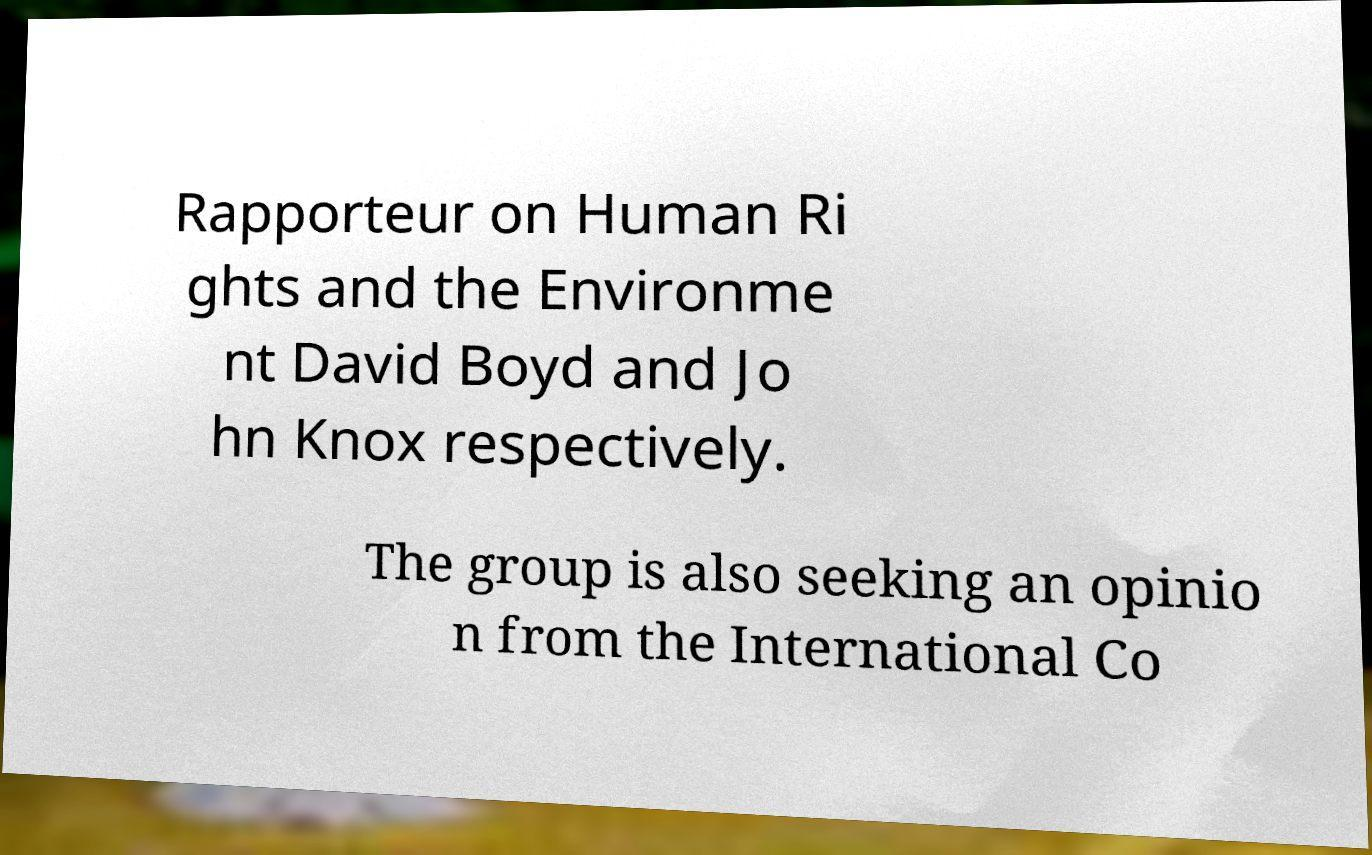Can you read and provide the text displayed in the image?This photo seems to have some interesting text. Can you extract and type it out for me? Rapporteur on Human Ri ghts and the Environme nt David Boyd and Jo hn Knox respectively. The group is also seeking an opinio n from the International Co 